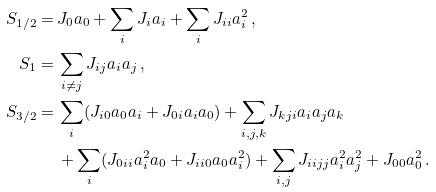Convert formula to latex. <formula><loc_0><loc_0><loc_500><loc_500>S _ { 1 / 2 } = & \, J _ { 0 } a _ { 0 } + \sum _ { i } J _ { i } a _ { i } + \sum _ { i } J _ { i i } a _ { i } ^ { 2 } \, , \\ S _ { 1 } = & \, \sum _ { i \neq j } J _ { i j } a _ { i } a _ { j } \, , \\ S _ { 3 / 2 } = & \, \sum _ { i } ( J _ { i 0 } a _ { 0 } a _ { i } + J _ { 0 i } a _ { i } a _ { 0 } ) + \sum _ { i , j , k } J _ { k j i } a _ { i } a _ { j } a _ { k } \\ & \, + \sum _ { i } ( J _ { 0 i i } a _ { i } ^ { 2 } a _ { 0 } + J _ { i i 0 } a _ { 0 } a _ { i } ^ { 2 } ) + \sum _ { i , j } J _ { i i j j } a _ { i } ^ { 2 } a _ { j } ^ { 2 } + J _ { 0 0 } a _ { 0 } ^ { 2 } \, .</formula> 